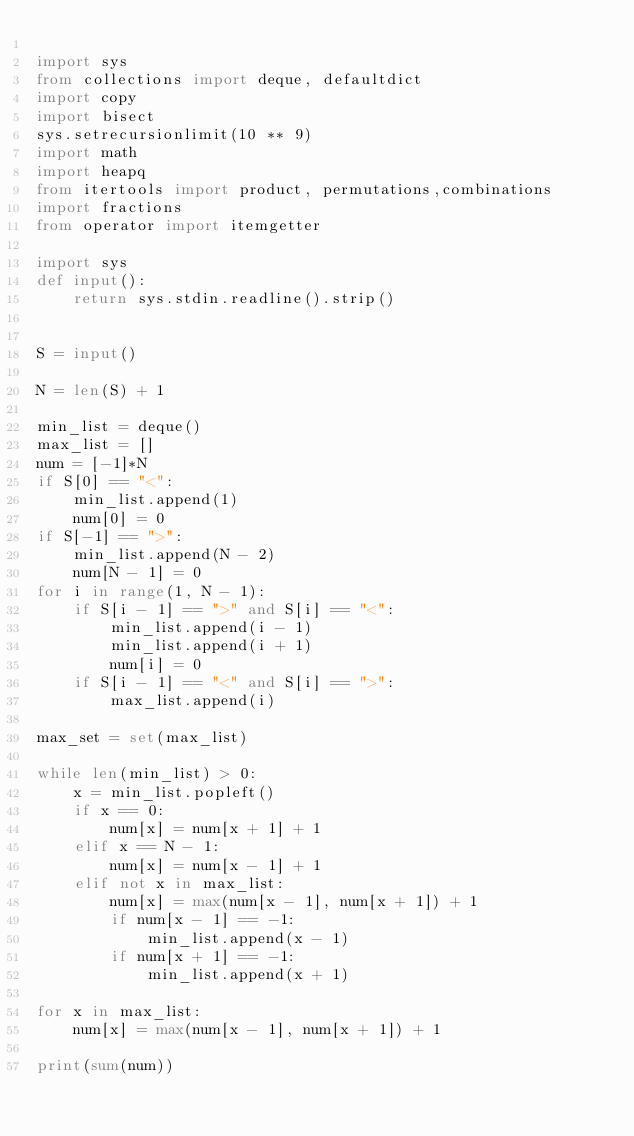<code> <loc_0><loc_0><loc_500><loc_500><_Python_>
import sys
from collections import deque, defaultdict
import copy
import bisect
sys.setrecursionlimit(10 ** 9)
import math
import heapq
from itertools import product, permutations,combinations
import fractions
from operator import itemgetter

import sys
def input():
	return sys.stdin.readline().strip()


S = input()

N = len(S) + 1

min_list = deque()
max_list = []
num = [-1]*N
if S[0] == "<":
	min_list.append(1)
	num[0] = 0
if S[-1] == ">":
	min_list.append(N - 2)
	num[N - 1] = 0
for i in range(1, N - 1):
	if S[i - 1] == ">" and S[i] == "<":
		min_list.append(i - 1)
		min_list.append(i + 1)
		num[i] = 0
	if S[i - 1] == "<" and S[i] == ">":
		max_list.append(i)

max_set = set(max_list)

while len(min_list) > 0:
	x = min_list.popleft()
	if x == 0:
		num[x] = num[x + 1] + 1
	elif x == N - 1:
		num[x] = num[x - 1] + 1
	elif not x in max_list:
		num[x] = max(num[x - 1], num[x + 1]) + 1
		if num[x - 1] == -1:
			min_list.append(x - 1)
		if num[x + 1] == -1:
			min_list.append(x + 1)

for x in max_list:
	num[x] = max(num[x - 1], num[x + 1]) + 1

print(sum(num))</code> 